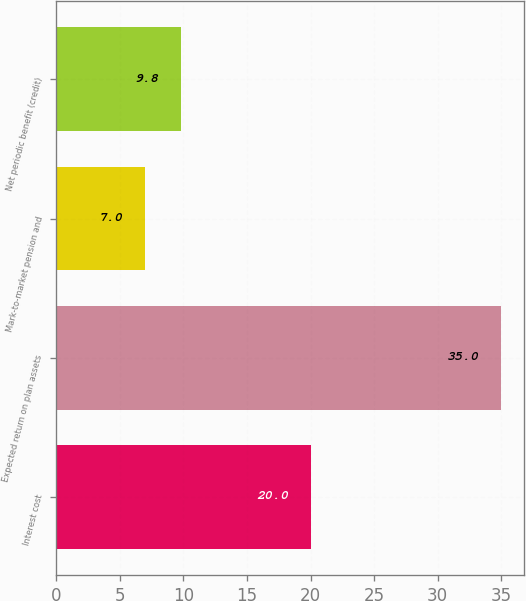<chart> <loc_0><loc_0><loc_500><loc_500><bar_chart><fcel>Interest cost<fcel>Expected return on plan assets<fcel>Mark-to-market pension and<fcel>Net periodic benefit (credit)<nl><fcel>20<fcel>35<fcel>7<fcel>9.8<nl></chart> 